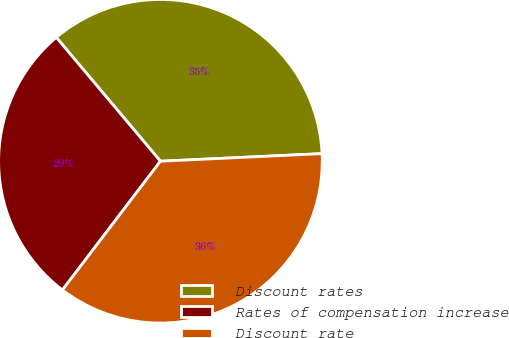Convert chart to OTSL. <chart><loc_0><loc_0><loc_500><loc_500><pie_chart><fcel>Discount rates<fcel>Rates of compensation increase<fcel>Discount rate<nl><fcel>35.38%<fcel>28.52%<fcel>36.1%<nl></chart> 